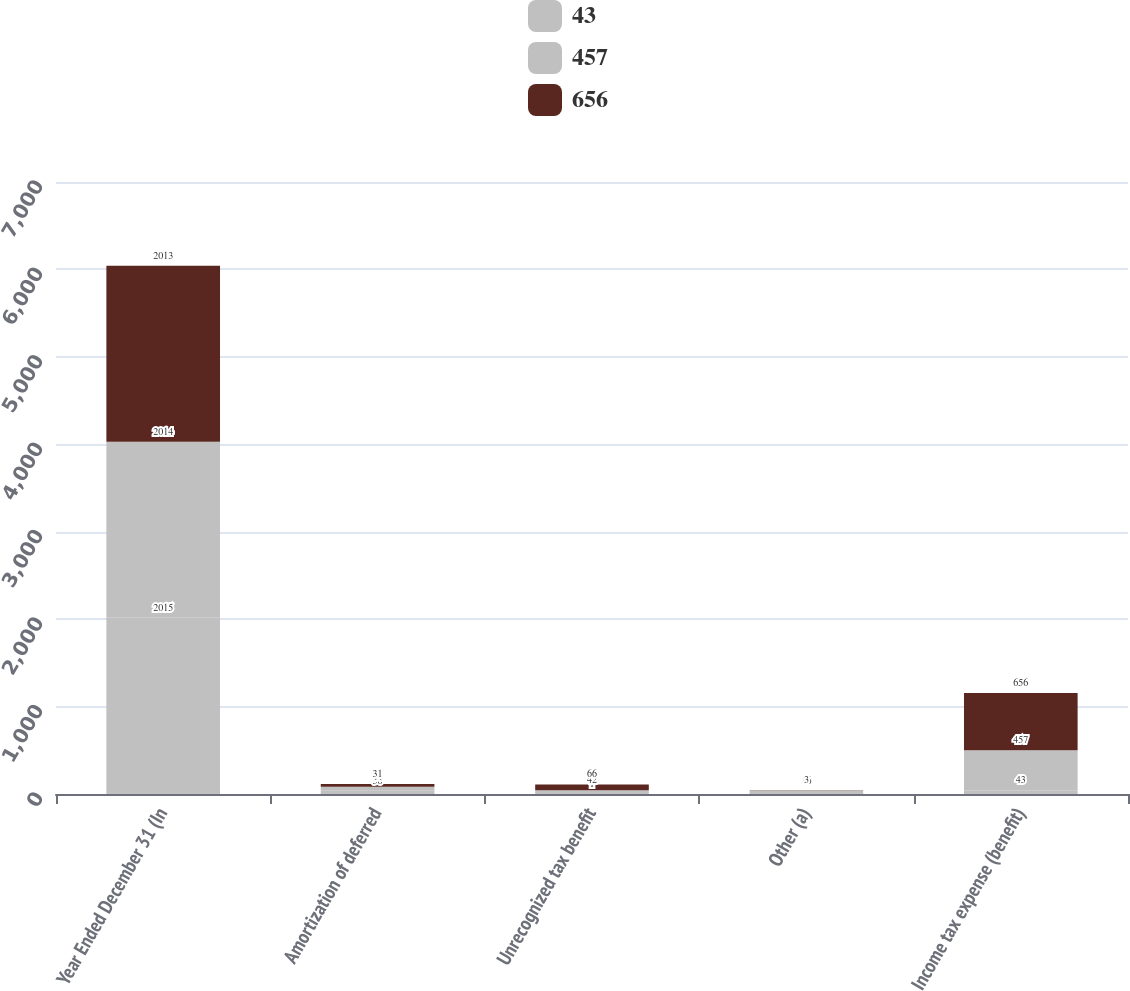<chart> <loc_0><loc_0><loc_500><loc_500><stacked_bar_chart><ecel><fcel>Year Ended December 31 (In<fcel>Amortization of deferred<fcel>Unrecognized tax benefit<fcel>Other (a)<fcel>Income tax expense (benefit)<nl><fcel>43<fcel>2015<fcel>38<fcel>1<fcel>24<fcel>43<nl><fcel>457<fcel>2014<fcel>44<fcel>42<fcel>16<fcel>457<nl><fcel>656<fcel>2013<fcel>31<fcel>66<fcel>3<fcel>656<nl></chart> 